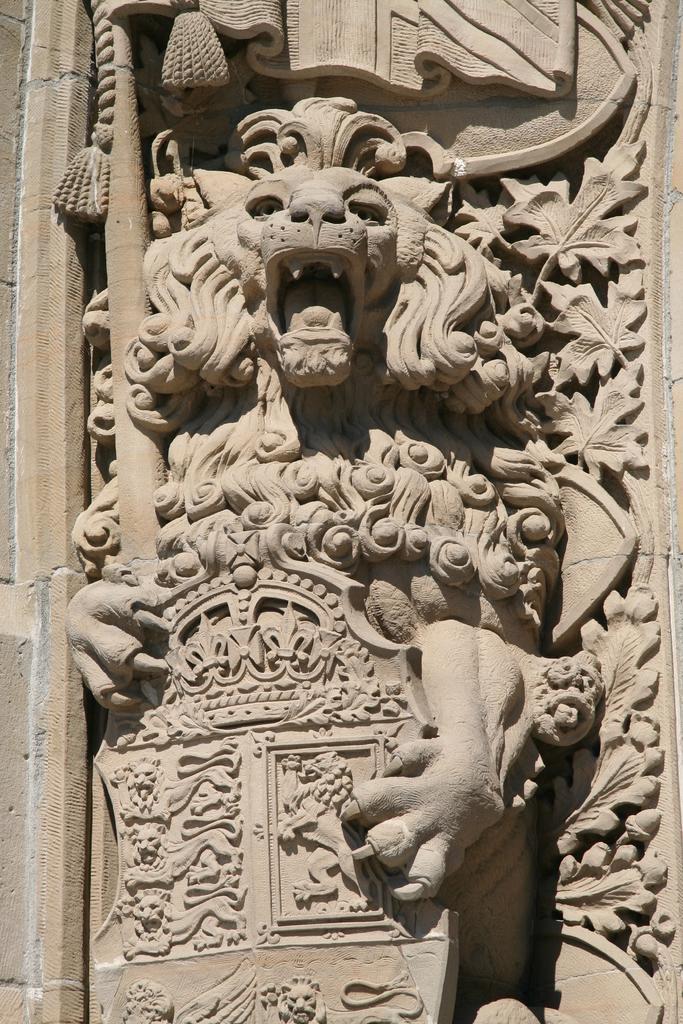Could you give a brief overview of what you see in this image? In this picture we can see a sculpture. 